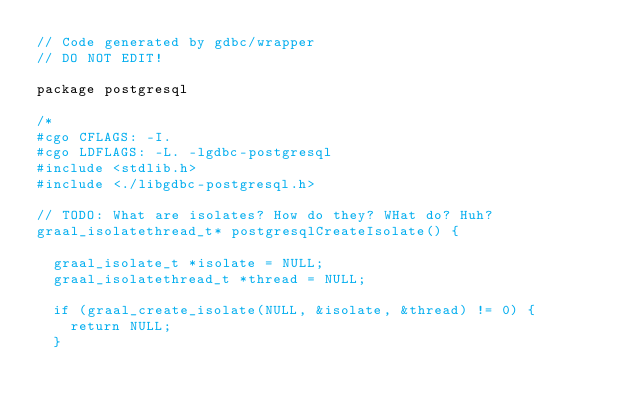Convert code to text. <code><loc_0><loc_0><loc_500><loc_500><_Go_>// Code generated by gdbc/wrapper
// DO NOT EDIT!

package postgresql

/*
#cgo CFLAGS: -I.
#cgo LDFLAGS: -L. -lgdbc-postgresql
#include <stdlib.h>
#include <./libgdbc-postgresql.h>

// TODO: What are isolates? How do they? WHat do? Huh?
graal_isolatethread_t* postgresqlCreateIsolate() {

  graal_isolate_t *isolate = NULL;
  graal_isolatethread_t *thread = NULL;

  if (graal_create_isolate(NULL, &isolate, &thread) != 0) {
	return NULL;
  }
</code> 